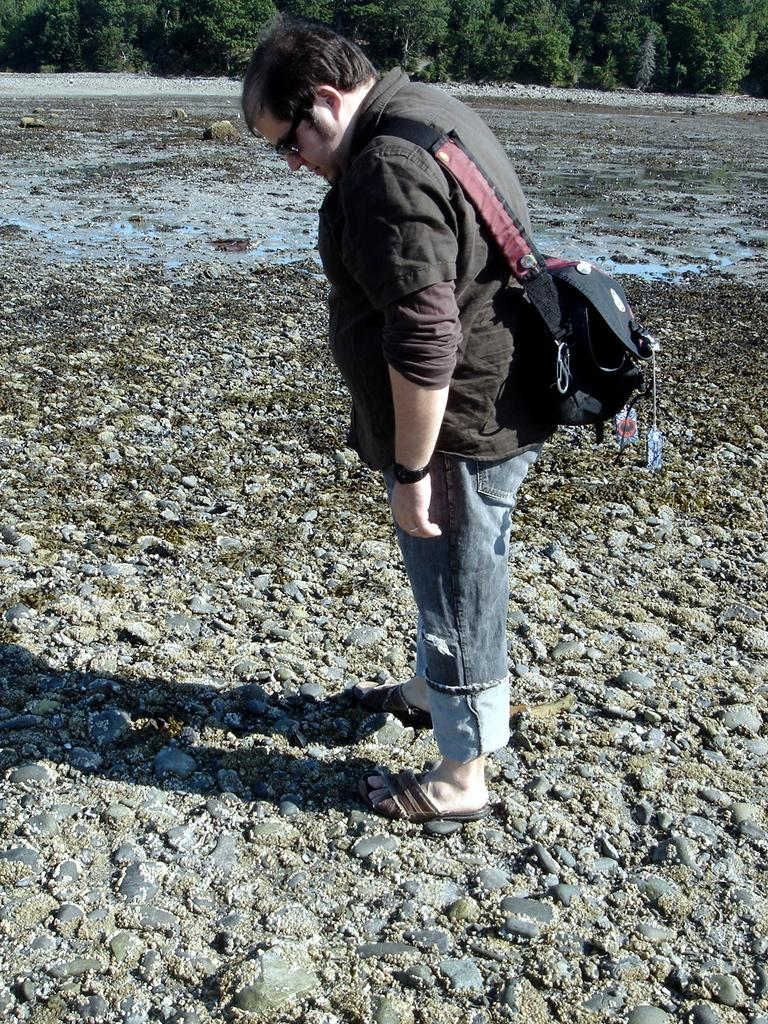What is the main subject in the foreground of the image? There is a man standing in the foreground of the image. What is the man wearing in the image? The man is wearing a backpack. What is the man standing on in the image? The man is standing on stones. What can be seen in the background of the image? There is water, stones, and trees visible in the background of the image. How many eggs are being carried by the cattle in the image? There are no cattle or eggs present in the image. What type of coal is visible in the image? There is no coal present in the image. 